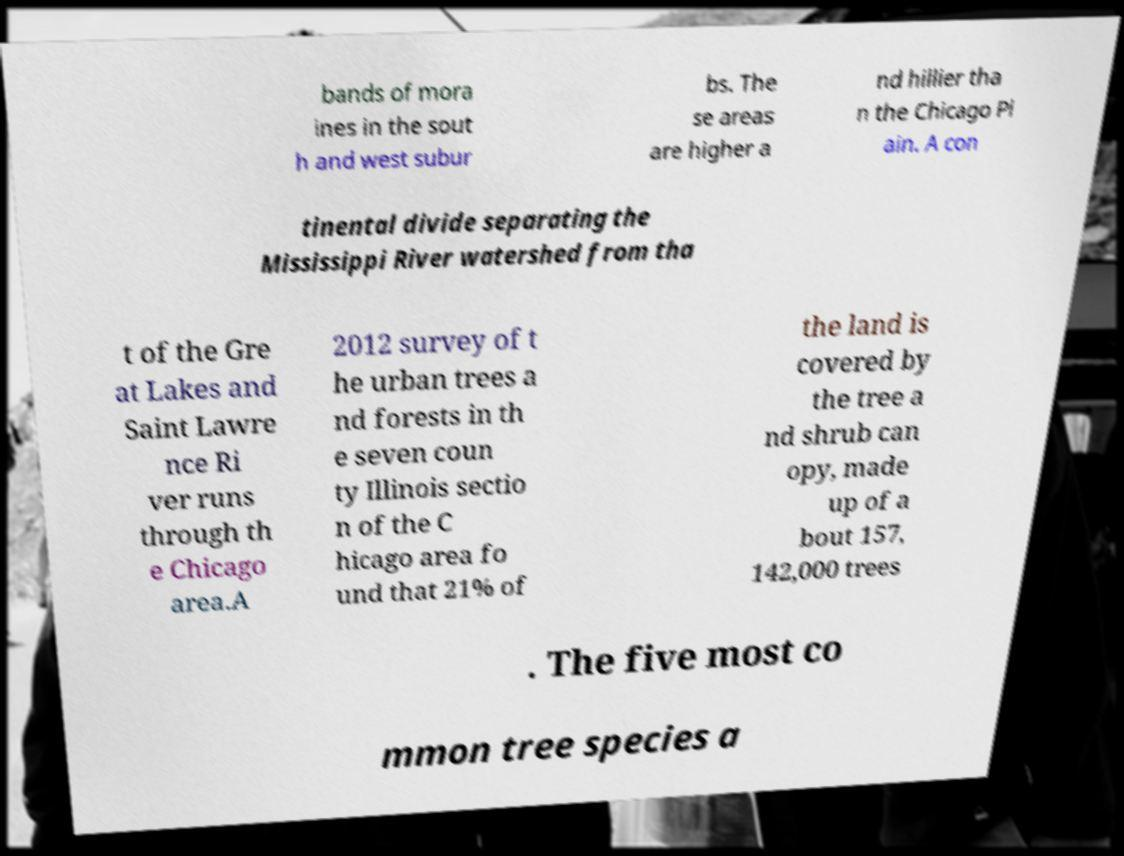Could you assist in decoding the text presented in this image and type it out clearly? bands of mora ines in the sout h and west subur bs. The se areas are higher a nd hillier tha n the Chicago Pl ain. A con tinental divide separating the Mississippi River watershed from tha t of the Gre at Lakes and Saint Lawre nce Ri ver runs through th e Chicago area.A 2012 survey of t he urban trees a nd forests in th e seven coun ty Illinois sectio n of the C hicago area fo und that 21% of the land is covered by the tree a nd shrub can opy, made up of a bout 157, 142,000 trees . The five most co mmon tree species a 